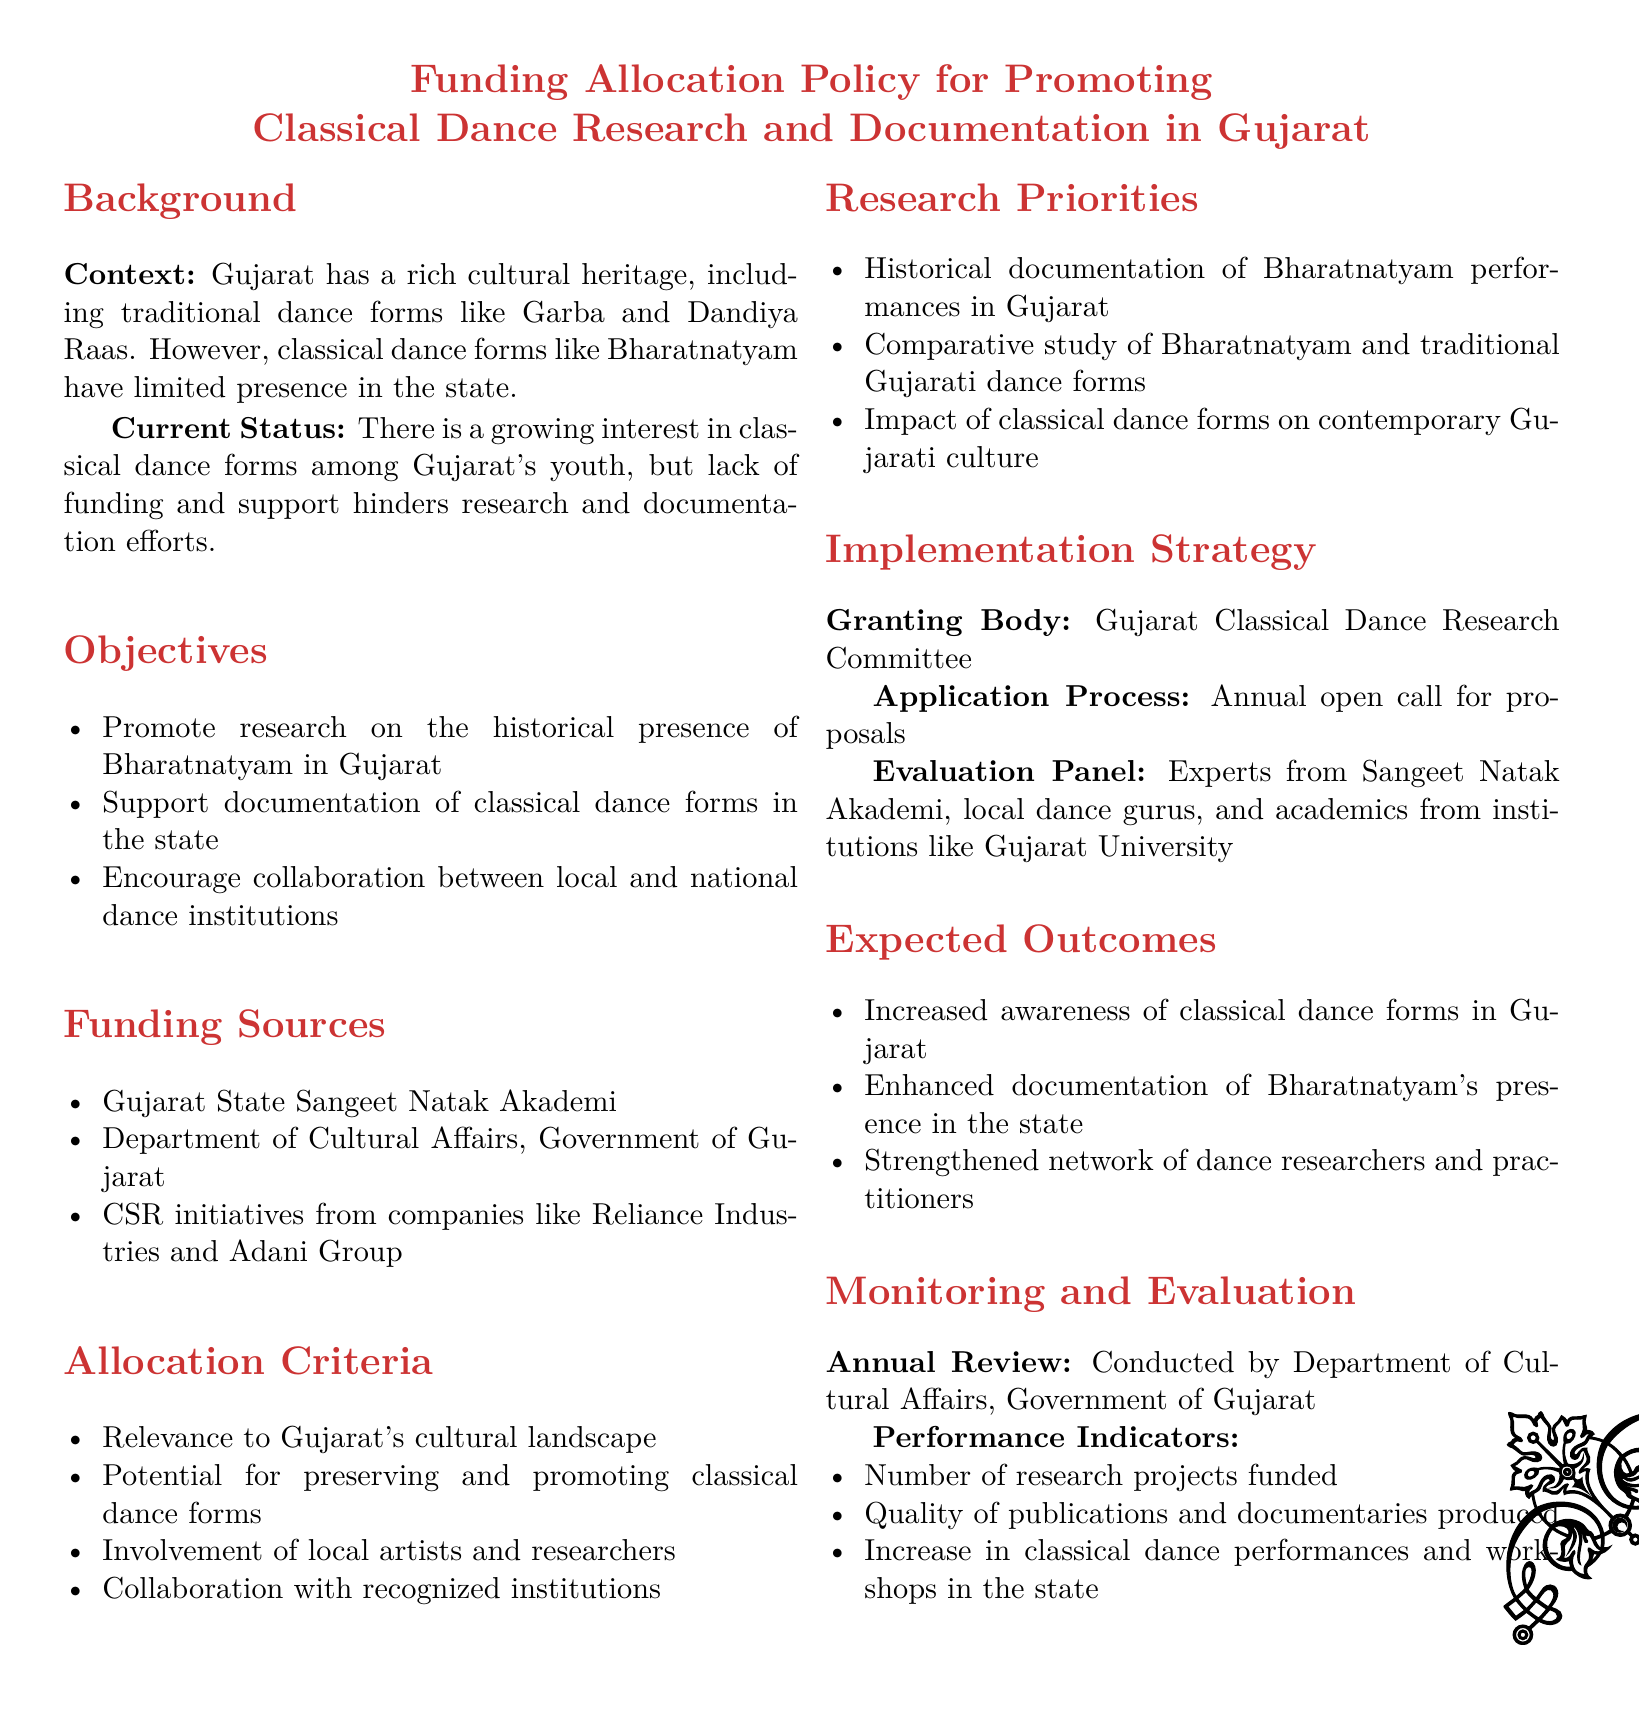What is the main title of the document? The main title is clearly stated at the beginning of the document, highlighting its focus on funding allocation for classical dance.
Answer: Funding Allocation Policy for Promoting Classical Dance Research and Documentation in Gujarat What is one of the objectives mentioned in the document? The document outlines specific goals, one of which includes promoting research on Bharatnatyam's historical presence.
Answer: Promote research on the historical presence of Bharatnatyam in Gujarat Which organization is listed as a funding source? The document specifies multiple funding sources, including state and corporate entities.
Answer: Gujarat State Sangeet Natak Akademi What is the granting body outlined in the implementation strategy? The document provides specifics on who will be responsible for granting the funds.
Answer: Gujarat Classical Dance Research Committee What is one of the research priorities specified in the document? The document includes various research priorities targeting Bharatnatyam and its relation to local culture.
Answer: Historical documentation of Bharatnatyam performances in Gujarat How often will the application process open for proposals? The document mentions the frequency of the application process, suggesting an annual review for funding applications.
Answer: Annual open call for proposals What is one performance indicator for monitoring and evaluation? Among the indicators listed, one specifically looks at the quantity of funded projects, which is vital for assessing success.
Answer: Number of research projects funded What collaboration is encouraged by the document? The objectives emphasize the importance of partnerships between regional and national institutions to enhance the program's reach.
Answer: Collaboration between local and national dance institutions 